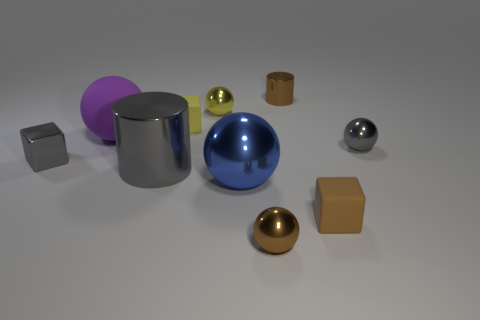Is the number of small gray spheres greater than the number of small brown shiny things?
Your answer should be compact. No. Is the size of the cube that is in front of the large cylinder the same as the rubber cube that is left of the small yellow ball?
Keep it short and to the point. Yes. What number of shiny cylinders are both in front of the tiny yellow metal object and to the right of the big blue sphere?
Offer a terse response. 0. There is a tiny metal thing that is the same shape as the tiny brown matte object; what color is it?
Provide a short and direct response. Gray. Are there fewer yellow balls than large brown shiny spheres?
Offer a terse response. No. Does the brown metal ball have the same size as the metal ball left of the large blue shiny thing?
Your answer should be very brief. Yes. There is a small cube right of the brown metallic object that is in front of the large matte sphere; what is its color?
Make the answer very short. Brown. What number of things are either spheres to the right of the big matte ball or large objects that are to the right of the tiny yellow ball?
Ensure brevity in your answer.  4. Is the gray sphere the same size as the gray shiny cylinder?
Give a very brief answer. No. Is there any other thing that is the same size as the yellow matte object?
Ensure brevity in your answer.  Yes. 